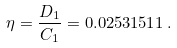<formula> <loc_0><loc_0><loc_500><loc_500>\eta = \frac { D _ { 1 } } { C _ { 1 } } = 0 . 0 2 5 3 1 5 1 1 \, .</formula> 